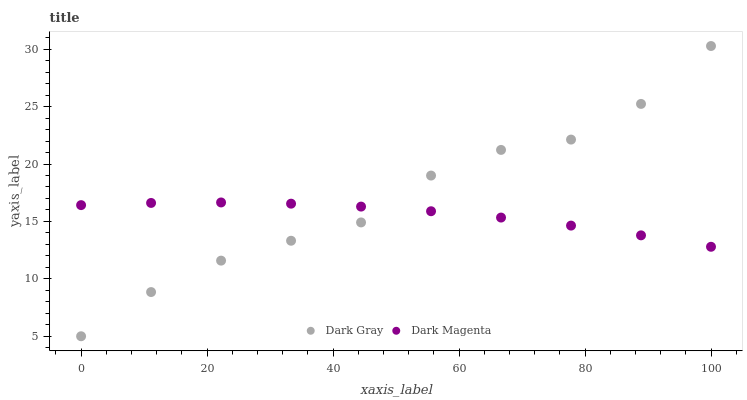Does Dark Magenta have the minimum area under the curve?
Answer yes or no. Yes. Does Dark Gray have the maximum area under the curve?
Answer yes or no. Yes. Does Dark Magenta have the maximum area under the curve?
Answer yes or no. No. Is Dark Magenta the smoothest?
Answer yes or no. Yes. Is Dark Gray the roughest?
Answer yes or no. Yes. Is Dark Magenta the roughest?
Answer yes or no. No. Does Dark Gray have the lowest value?
Answer yes or no. Yes. Does Dark Magenta have the lowest value?
Answer yes or no. No. Does Dark Gray have the highest value?
Answer yes or no. Yes. Does Dark Magenta have the highest value?
Answer yes or no. No. Does Dark Magenta intersect Dark Gray?
Answer yes or no. Yes. Is Dark Magenta less than Dark Gray?
Answer yes or no. No. Is Dark Magenta greater than Dark Gray?
Answer yes or no. No. 